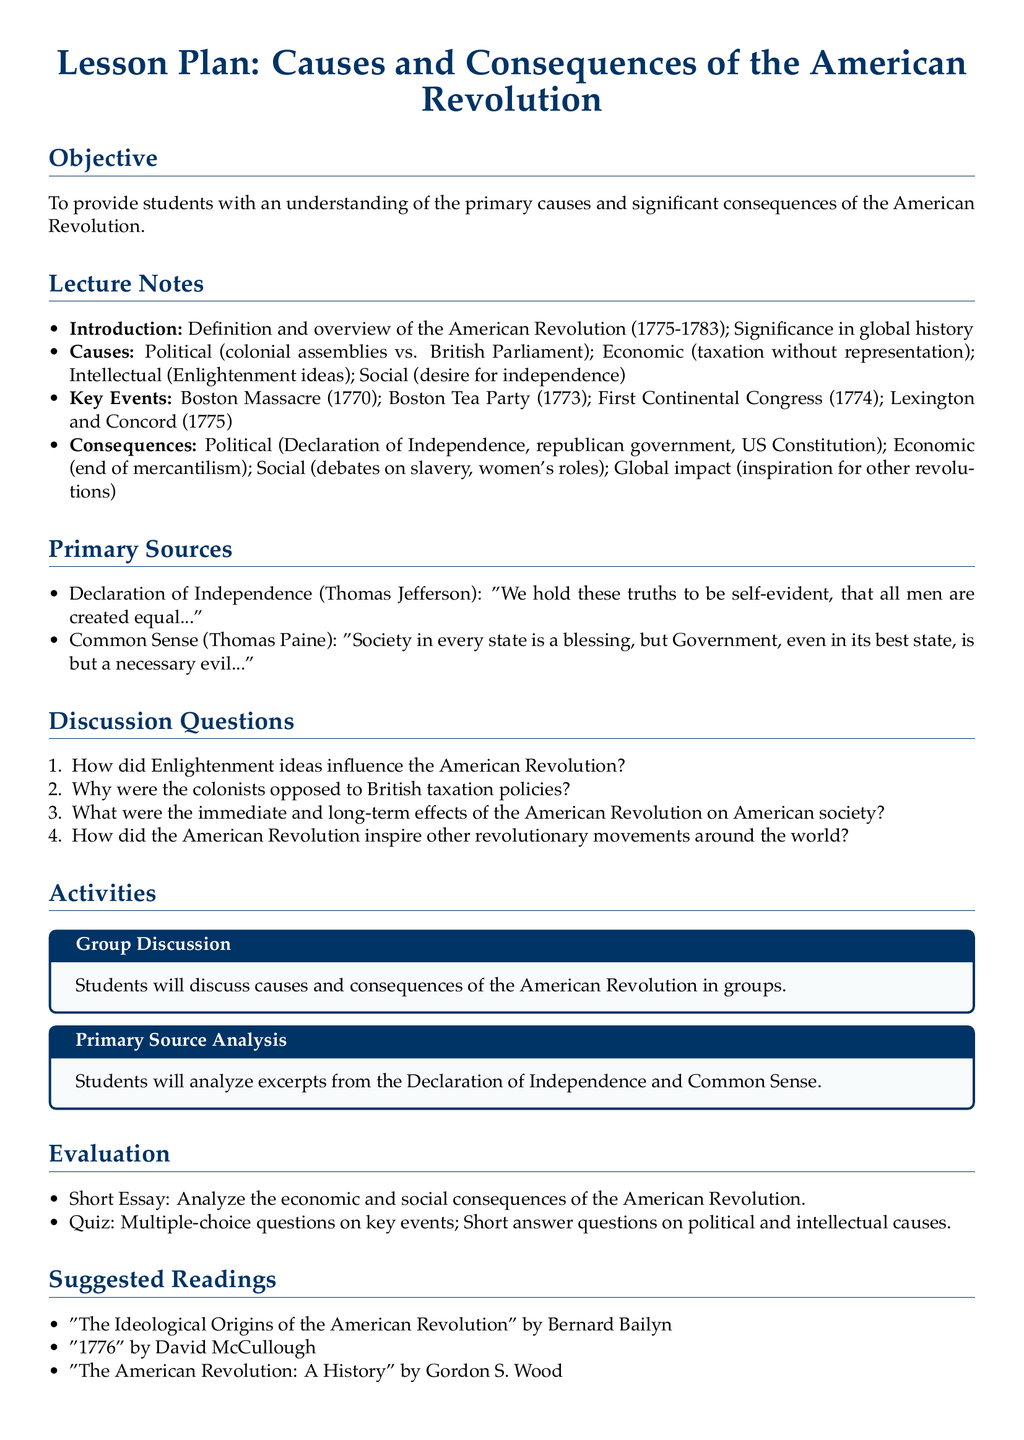What is the time period of the American Revolution? The time period of the American Revolution is specified in the document as 1775-1783.
Answer: 1775-1783 Who wrote the Declaration of Independence? The document specifies that the Declaration of Independence was written by Thomas Jefferson.
Answer: Thomas Jefferson What is one of the key events listed that occurred in 1773? The document mentions the Boston Tea Party as a key event that occurred in 1773.
Answer: Boston Tea Party What is one of the suggested readings? The document includes "The Ideological Origins of the American Revolution" by Bernard Bailyn as a suggested reading.
Answer: "The Ideological Origins of the American Revolution" How does the document categorize the causes of the American Revolution? The document categorizes the causes into political, economic, intellectual, and social groups.
Answer: Political, economic, intellectual, social What is a consequence of the American Revolution mentioned in the document? The document lists the establishment of a republican government as a consequence of the American Revolution.
Answer: Republican government What type of activity involves primary source analysis? The document describes an activity where students will analyze excerpts from the Declaration of Independence and Common Sense.
Answer: Primary Source Analysis How many discussion questions are provided in the document? The document lists four discussion questions under the discussion section.
Answer: Four What was one of Thomas Paine's key points in "Common Sense"? The document notes that Thomas Paine stated, "Government, even in its best state, is but a necessary evil."
Answer: Necessary evil 